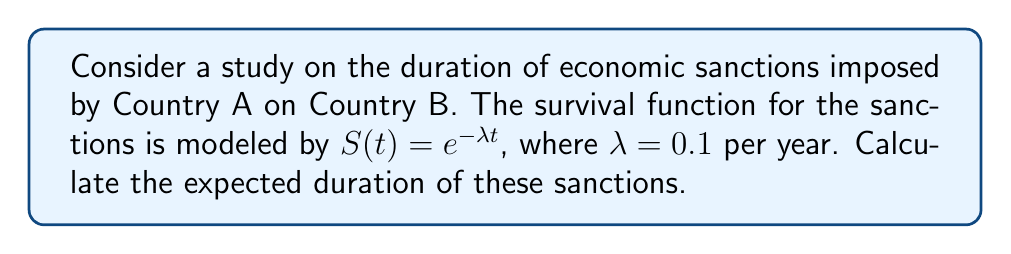What is the answer to this math problem? To solve this problem, we'll follow these steps:

1) In survival analysis, the expected value (mean) of a continuous random variable T with survival function S(t) is given by:

   $$E[T] = \int_0^\infty S(t) dt$$

2) We're given that $S(t) = e^{-\lambda t}$ with $\lambda = 0.1$ per year.

3) Let's substitute this into our formula:

   $$E[T] = \int_0^\infty e^{-0.1t} dt$$

4) To solve this integral, we can use the fact that $\int e^{ax} dx = \frac{1}{a}e^{ax} + C$

5) Applying this:

   $$E[T] = [-10e^{-0.1t}]_0^\infty$$

6) Evaluating the limits:

   $$E[T] = \lim_{t \to \infty} (-10e^{-0.1t}) - (-10e^{-0.1(0)})$$
   $$E[T] = 0 - (-10) = 10$$

Therefore, the expected duration of the sanctions is 10 years.
Answer: 10 years 